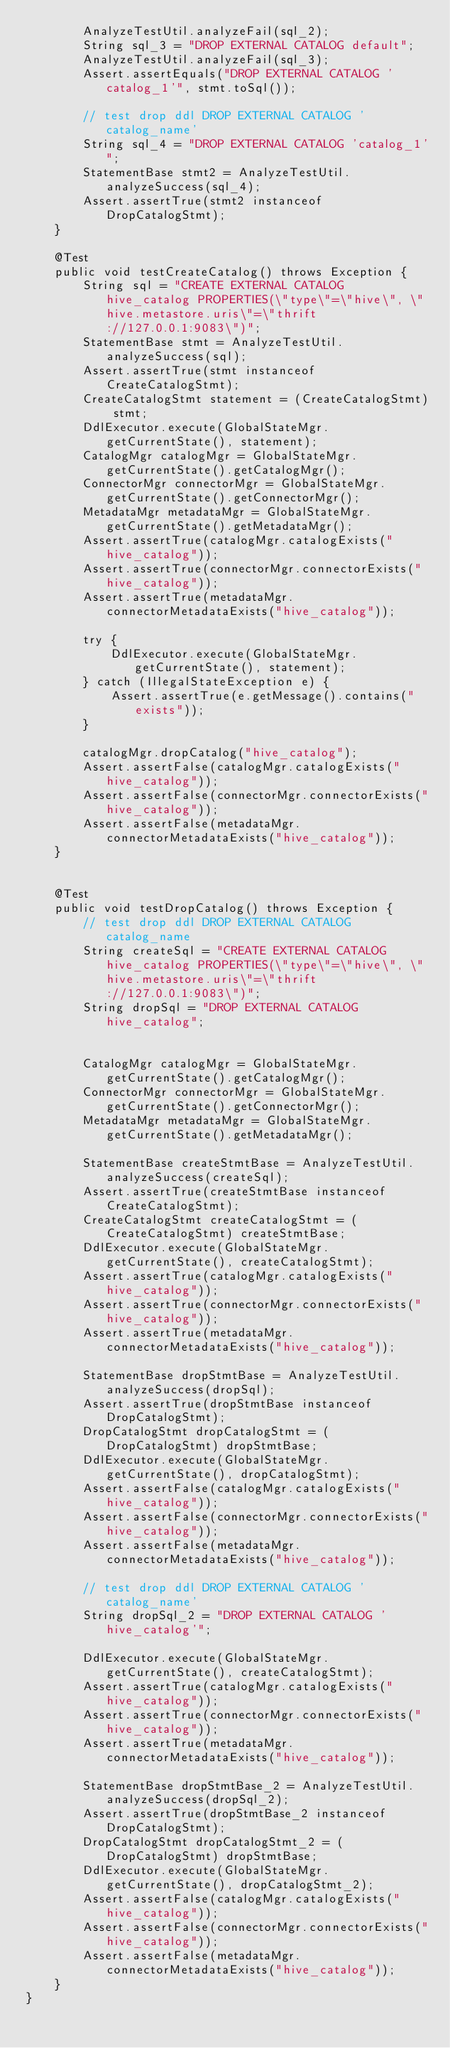Convert code to text. <code><loc_0><loc_0><loc_500><loc_500><_Java_>        AnalyzeTestUtil.analyzeFail(sql_2);
        String sql_3 = "DROP EXTERNAL CATALOG default";
        AnalyzeTestUtil.analyzeFail(sql_3);
        Assert.assertEquals("DROP EXTERNAL CATALOG 'catalog_1'", stmt.toSql());

        // test drop ddl DROP EXTERNAL CATALOG 'catalog_name'
        String sql_4 = "DROP EXTERNAL CATALOG 'catalog_1'";
        StatementBase stmt2 = AnalyzeTestUtil.analyzeSuccess(sql_4);
        Assert.assertTrue(stmt2 instanceof DropCatalogStmt);
    }

    @Test
    public void testCreateCatalog() throws Exception {
        String sql = "CREATE EXTERNAL CATALOG hive_catalog PROPERTIES(\"type\"=\"hive\", \"hive.metastore.uris\"=\"thrift://127.0.0.1:9083\")";
        StatementBase stmt = AnalyzeTestUtil.analyzeSuccess(sql);
        Assert.assertTrue(stmt instanceof CreateCatalogStmt);
        CreateCatalogStmt statement = (CreateCatalogStmt) stmt;
        DdlExecutor.execute(GlobalStateMgr.getCurrentState(), statement);
        CatalogMgr catalogMgr = GlobalStateMgr.getCurrentState().getCatalogMgr();
        ConnectorMgr connectorMgr = GlobalStateMgr.getCurrentState().getConnectorMgr();
        MetadataMgr metadataMgr = GlobalStateMgr.getCurrentState().getMetadataMgr();
        Assert.assertTrue(catalogMgr.catalogExists("hive_catalog"));
        Assert.assertTrue(connectorMgr.connectorExists("hive_catalog"));
        Assert.assertTrue(metadataMgr.connectorMetadataExists("hive_catalog"));

        try {
            DdlExecutor.execute(GlobalStateMgr.getCurrentState(), statement);
        } catch (IllegalStateException e) {
            Assert.assertTrue(e.getMessage().contains("exists"));
        }

        catalogMgr.dropCatalog("hive_catalog");
        Assert.assertFalse(catalogMgr.catalogExists("hive_catalog"));
        Assert.assertFalse(connectorMgr.connectorExists("hive_catalog"));
        Assert.assertFalse(metadataMgr.connectorMetadataExists("hive_catalog"));
    }


    @Test
    public void testDropCatalog() throws Exception {
        // test drop ddl DROP EXTERNAL CATALOG catalog_name
        String createSql = "CREATE EXTERNAL CATALOG hive_catalog PROPERTIES(\"type\"=\"hive\", \"hive.metastore.uris\"=\"thrift://127.0.0.1:9083\")";
        String dropSql = "DROP EXTERNAL CATALOG hive_catalog";


        CatalogMgr catalogMgr = GlobalStateMgr.getCurrentState().getCatalogMgr();
        ConnectorMgr connectorMgr = GlobalStateMgr.getCurrentState().getConnectorMgr();
        MetadataMgr metadataMgr = GlobalStateMgr.getCurrentState().getMetadataMgr();

        StatementBase createStmtBase = AnalyzeTestUtil.analyzeSuccess(createSql);
        Assert.assertTrue(createStmtBase instanceof CreateCatalogStmt);
        CreateCatalogStmt createCatalogStmt = (CreateCatalogStmt) createStmtBase;
        DdlExecutor.execute(GlobalStateMgr.getCurrentState(), createCatalogStmt);
        Assert.assertTrue(catalogMgr.catalogExists("hive_catalog"));
        Assert.assertTrue(connectorMgr.connectorExists("hive_catalog"));
        Assert.assertTrue(metadataMgr.connectorMetadataExists("hive_catalog"));

        StatementBase dropStmtBase = AnalyzeTestUtil.analyzeSuccess(dropSql);
        Assert.assertTrue(dropStmtBase instanceof DropCatalogStmt);
        DropCatalogStmt dropCatalogStmt = (DropCatalogStmt) dropStmtBase;
        DdlExecutor.execute(GlobalStateMgr.getCurrentState(), dropCatalogStmt);
        Assert.assertFalse(catalogMgr.catalogExists("hive_catalog"));
        Assert.assertFalse(connectorMgr.connectorExists("hive_catalog"));
        Assert.assertFalse(metadataMgr.connectorMetadataExists("hive_catalog"));

        // test drop ddl DROP EXTERNAL CATALOG 'catalog_name'
        String dropSql_2 = "DROP EXTERNAL CATALOG 'hive_catalog'";

        DdlExecutor.execute(GlobalStateMgr.getCurrentState(), createCatalogStmt);
        Assert.assertTrue(catalogMgr.catalogExists("hive_catalog"));
        Assert.assertTrue(connectorMgr.connectorExists("hive_catalog"));
        Assert.assertTrue(metadataMgr.connectorMetadataExists("hive_catalog"));

        StatementBase dropStmtBase_2 = AnalyzeTestUtil.analyzeSuccess(dropSql_2);
        Assert.assertTrue(dropStmtBase_2 instanceof DropCatalogStmt);
        DropCatalogStmt dropCatalogStmt_2 = (DropCatalogStmt) dropStmtBase;
        DdlExecutor.execute(GlobalStateMgr.getCurrentState(), dropCatalogStmt_2);
        Assert.assertFalse(catalogMgr.catalogExists("hive_catalog"));
        Assert.assertFalse(connectorMgr.connectorExists("hive_catalog"));
        Assert.assertFalse(metadataMgr.connectorMetadataExists("hive_catalog"));
    }
}
</code> 